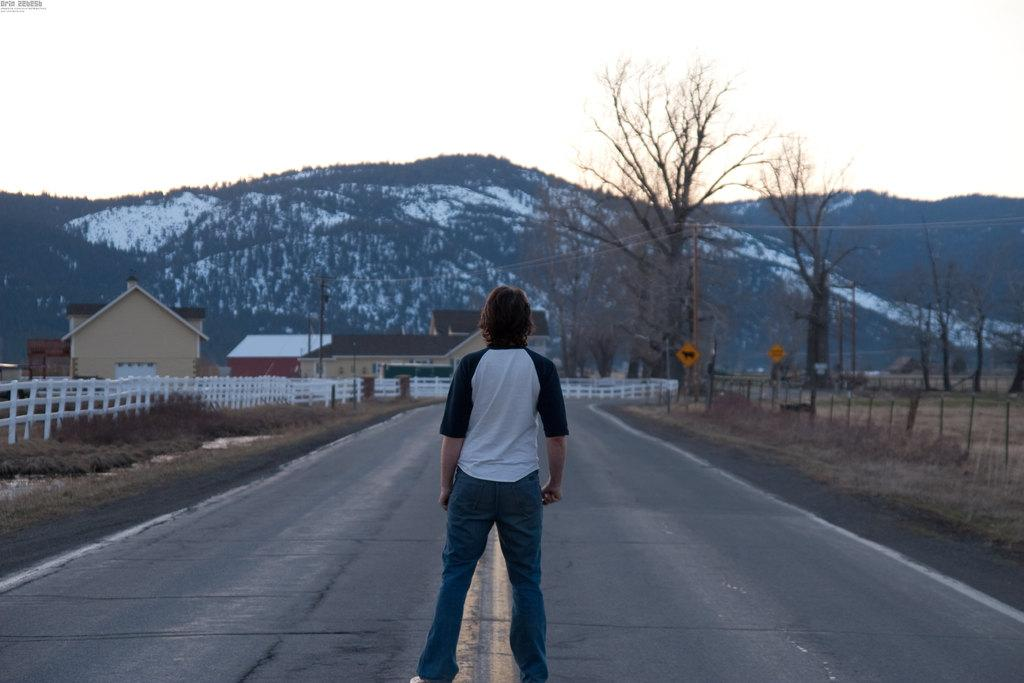What is the man in the image doing? The man is standing on the road in the image. What can be seen on the left side of the image? There is a fence on the left side of the image. What type of structures are visible in the image? There are sheds visible in the image. What can be seen in the background of the image? There are trees, hills, and the sky visible in the background of the image. What type of whip is the man holding in the image? There is no whip present in the image; the man is simply standing on the road. 